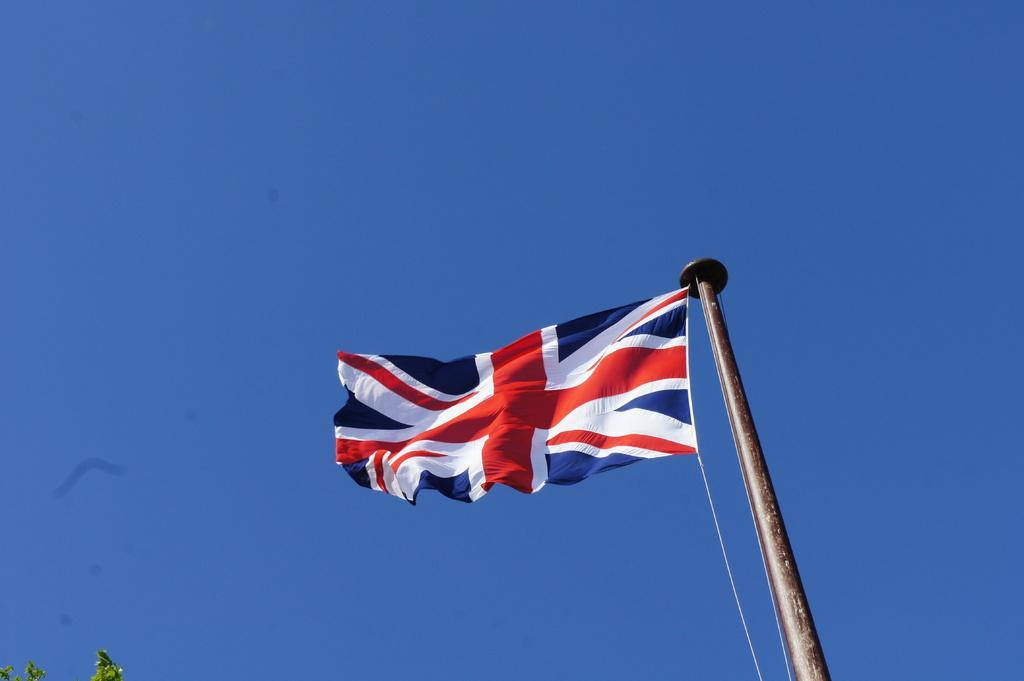Describe this image in one or two sentences. In the center of the image, we can see a flag and in the background, there is a sky. At the bottom, we can see some leaves. 